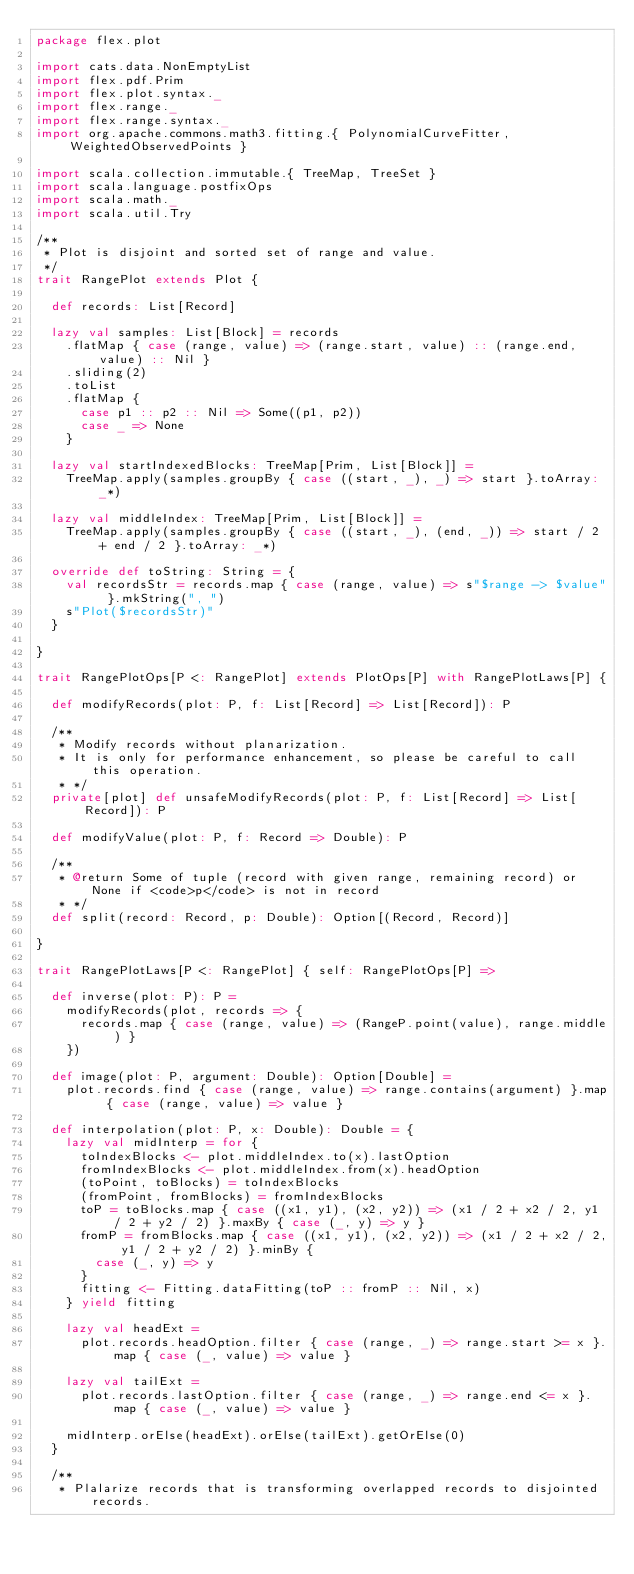Convert code to text. <code><loc_0><loc_0><loc_500><loc_500><_Scala_>package flex.plot

import cats.data.NonEmptyList
import flex.pdf.Prim
import flex.plot.syntax._
import flex.range._
import flex.range.syntax._
import org.apache.commons.math3.fitting.{ PolynomialCurveFitter, WeightedObservedPoints }

import scala.collection.immutable.{ TreeMap, TreeSet }
import scala.language.postfixOps
import scala.math._
import scala.util.Try

/**
 * Plot is disjoint and sorted set of range and value.
 */
trait RangePlot extends Plot {

  def records: List[Record]

  lazy val samples: List[Block] = records
    .flatMap { case (range, value) => (range.start, value) :: (range.end, value) :: Nil }
    .sliding(2)
    .toList
    .flatMap {
      case p1 :: p2 :: Nil => Some((p1, p2))
      case _ => None
    }

  lazy val startIndexedBlocks: TreeMap[Prim, List[Block]] =
    TreeMap.apply(samples.groupBy { case ((start, _), _) => start }.toArray: _*)

  lazy val middleIndex: TreeMap[Prim, List[Block]] =
    TreeMap.apply(samples.groupBy { case ((start, _), (end, _)) => start / 2 + end / 2 }.toArray: _*)

  override def toString: String = {
    val recordsStr = records.map { case (range, value) => s"$range -> $value" }.mkString(", ")
    s"Plot($recordsStr)"
  }

}

trait RangePlotOps[P <: RangePlot] extends PlotOps[P] with RangePlotLaws[P] {

  def modifyRecords(plot: P, f: List[Record] => List[Record]): P

  /**
   * Modify records without planarization.
   * It is only for performance enhancement, so please be careful to call this operation.
   * */
  private[plot] def unsafeModifyRecords(plot: P, f: List[Record] => List[Record]): P

  def modifyValue(plot: P, f: Record => Double): P

  /**
   * @return Some of tuple (record with given range, remaining record) or None if <code>p</code> is not in record
   * */
  def split(record: Record, p: Double): Option[(Record, Record)]

}

trait RangePlotLaws[P <: RangePlot] { self: RangePlotOps[P] =>

  def inverse(plot: P): P =
    modifyRecords(plot, records => {
      records.map { case (range, value) => (RangeP.point(value), range.middle) }
    })

  def image(plot: P, argument: Double): Option[Double] =
    plot.records.find { case (range, value) => range.contains(argument) }.map { case (range, value) => value }

  def interpolation(plot: P, x: Double): Double = {
    lazy val midInterp = for {
      toIndexBlocks <- plot.middleIndex.to(x).lastOption
      fromIndexBlocks <- plot.middleIndex.from(x).headOption
      (toPoint, toBlocks) = toIndexBlocks
      (fromPoint, fromBlocks) = fromIndexBlocks
      toP = toBlocks.map { case ((x1, y1), (x2, y2)) => (x1 / 2 + x2 / 2, y1 / 2 + y2 / 2) }.maxBy { case (_, y) => y }
      fromP = fromBlocks.map { case ((x1, y1), (x2, y2)) => (x1 / 2 + x2 / 2, y1 / 2 + y2 / 2) }.minBy {
        case (_, y) => y
      }
      fitting <- Fitting.dataFitting(toP :: fromP :: Nil, x)
    } yield fitting

    lazy val headExt =
      plot.records.headOption.filter { case (range, _) => range.start >= x }.map { case (_, value) => value }

    lazy val tailExt =
      plot.records.lastOption.filter { case (range, _) => range.end <= x }.map { case (_, value) => value }

    midInterp.orElse(headExt).orElse(tailExt).getOrElse(0)
  }

  /**
   * Plalarize records that is transforming overlapped records to disjointed records.</code> 